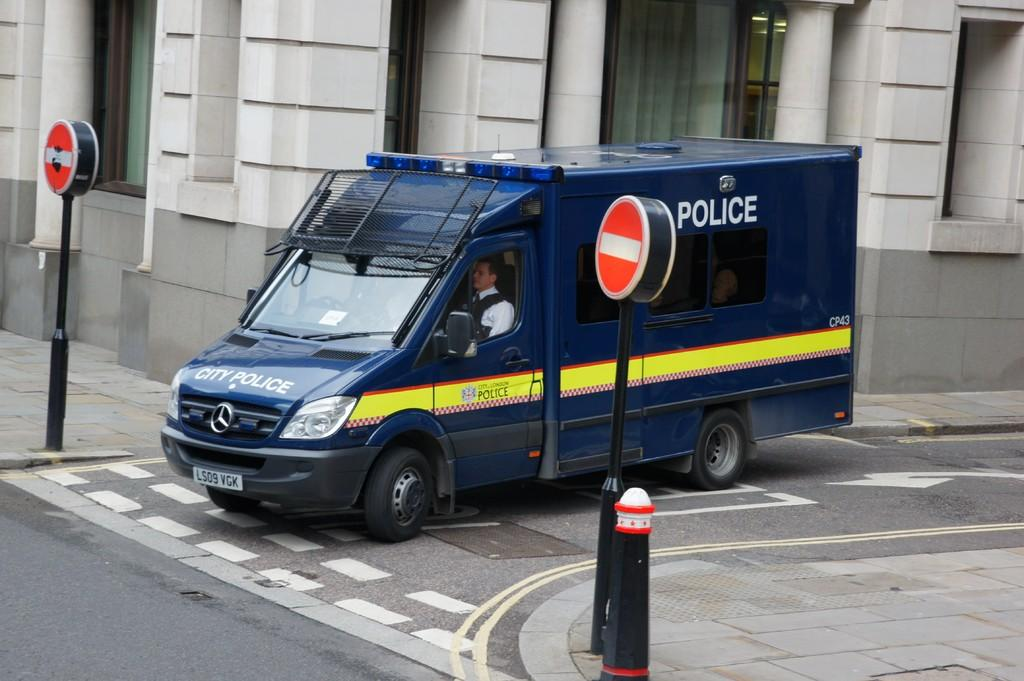<image>
Render a clear and concise summary of the photo. The licence plate for the police truck is LS09 VGK.. 